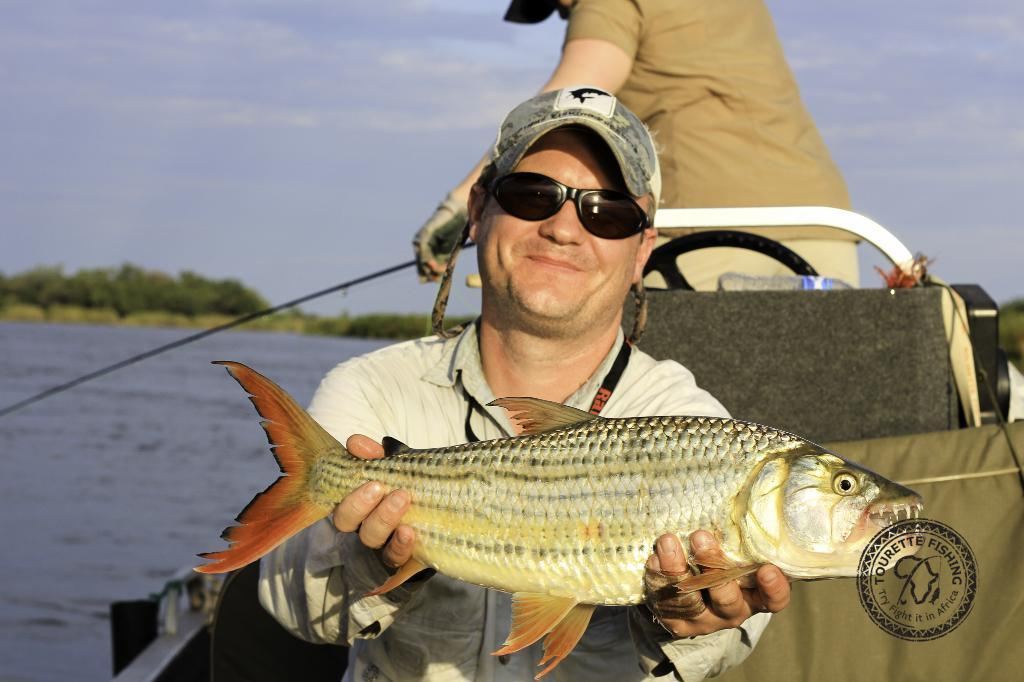What are the men in the image doing? The men in the image are standing in a boat. What is one of the men holding in his hands? One of the men is holding a fish in both hands. What can be seen in the background of the image? There is water, trees, and the sky visible in the background. What is the condition of the sky in the image? The sky is visible with clouds in the background. What type of music can be heard coming from the boat in the image? There is no indication in the image that music is being played, so it's not possible to determine what, if any, music might be heard. 